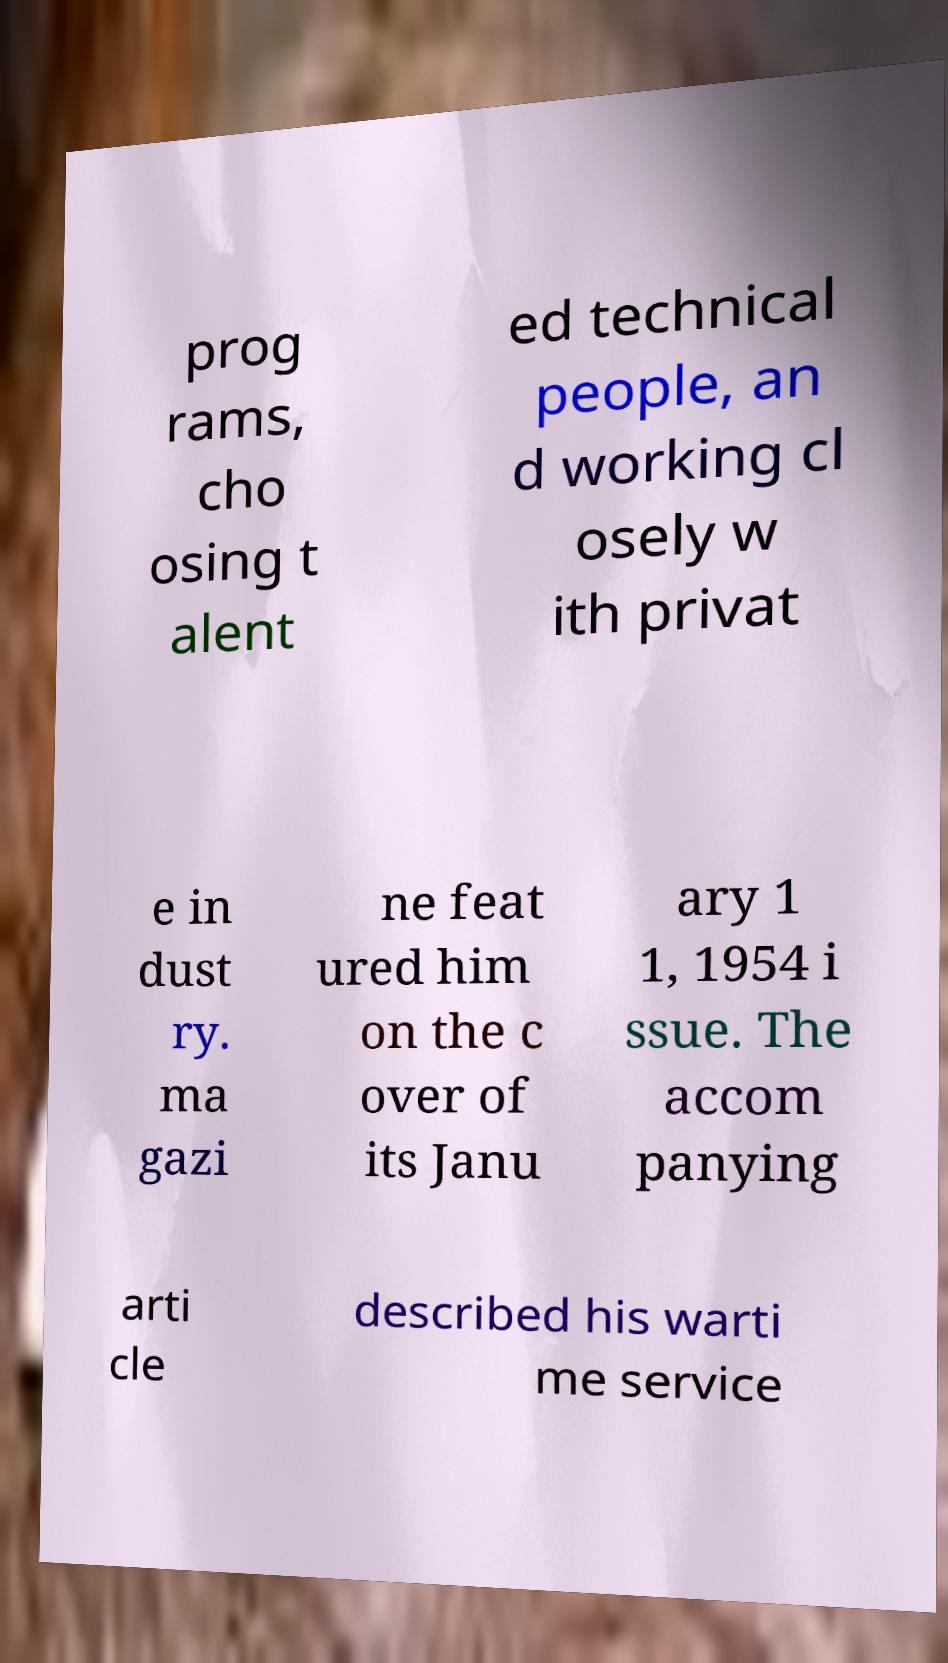I need the written content from this picture converted into text. Can you do that? prog rams, cho osing t alent ed technical people, an d working cl osely w ith privat e in dust ry. ma gazi ne feat ured him on the c over of its Janu ary 1 1, 1954 i ssue. The accom panying arti cle described his warti me service 